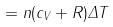<formula> <loc_0><loc_0><loc_500><loc_500>= n ( c _ { V } + R ) \Delta T</formula> 